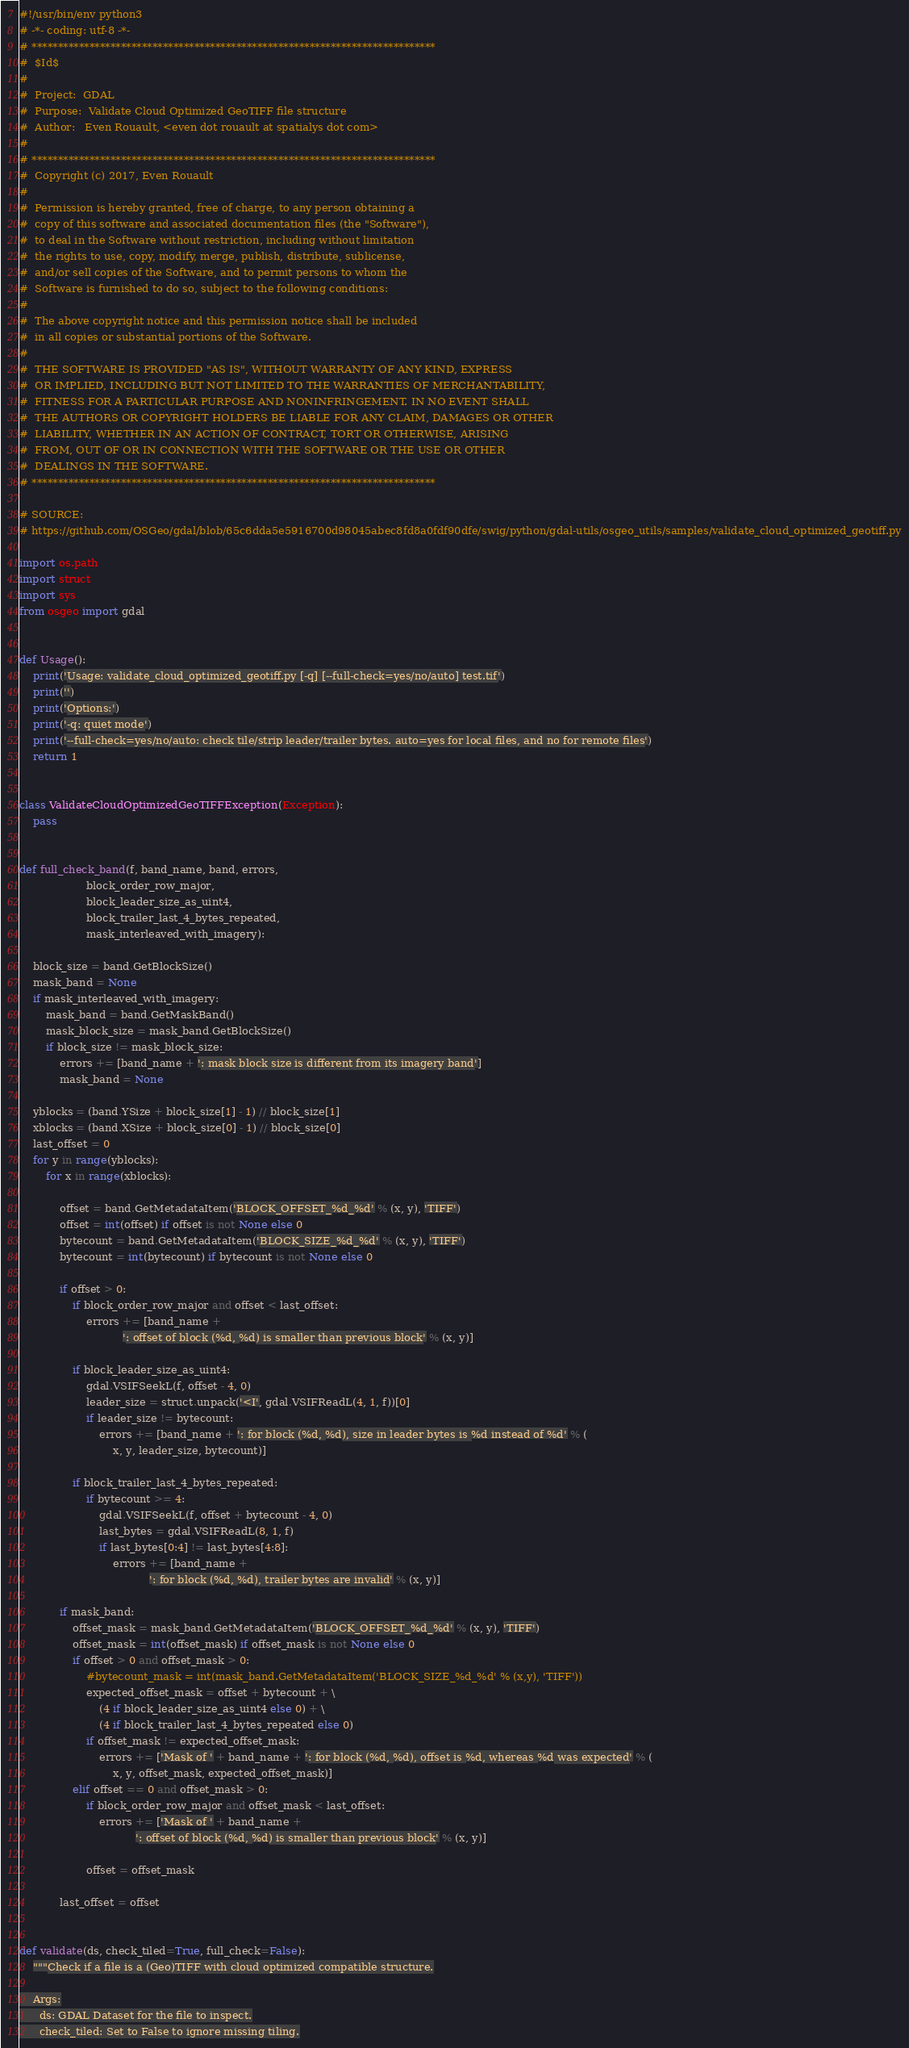<code> <loc_0><loc_0><loc_500><loc_500><_Python_>#!/usr/bin/env python3
# -*- coding: utf-8 -*-
# *****************************************************************************
#  $Id$
#
#  Project:  GDAL
#  Purpose:  Validate Cloud Optimized GeoTIFF file structure
#  Author:   Even Rouault, <even dot rouault at spatialys dot com>
#
# *****************************************************************************
#  Copyright (c) 2017, Even Rouault
#
#  Permission is hereby granted, free of charge, to any person obtaining a
#  copy of this software and associated documentation files (the "Software"),
#  to deal in the Software without restriction, including without limitation
#  the rights to use, copy, modify, merge, publish, distribute, sublicense,
#  and/or sell copies of the Software, and to permit persons to whom the
#  Software is furnished to do so, subject to the following conditions:
#
#  The above copyright notice and this permission notice shall be included
#  in all copies or substantial portions of the Software.
#
#  THE SOFTWARE IS PROVIDED "AS IS", WITHOUT WARRANTY OF ANY KIND, EXPRESS
#  OR IMPLIED, INCLUDING BUT NOT LIMITED TO THE WARRANTIES OF MERCHANTABILITY,
#  FITNESS FOR A PARTICULAR PURPOSE AND NONINFRINGEMENT. IN NO EVENT SHALL
#  THE AUTHORS OR COPYRIGHT HOLDERS BE LIABLE FOR ANY CLAIM, DAMAGES OR OTHER
#  LIABILITY, WHETHER IN AN ACTION OF CONTRACT, TORT OR OTHERWISE, ARISING
#  FROM, OUT OF OR IN CONNECTION WITH THE SOFTWARE OR THE USE OR OTHER
#  DEALINGS IN THE SOFTWARE.
# *****************************************************************************

# SOURCE:
# https://github.com/OSGeo/gdal/blob/65c6dda5e5916700d98045abec8fd8a0fdf90dfe/swig/python/gdal-utils/osgeo_utils/samples/validate_cloud_optimized_geotiff.py

import os.path
import struct
import sys
from osgeo import gdal


def Usage():
    print('Usage: validate_cloud_optimized_geotiff.py [-q] [--full-check=yes/no/auto] test.tif')
    print('')
    print('Options:')
    print('-q: quiet mode')
    print('--full-check=yes/no/auto: check tile/strip leader/trailer bytes. auto=yes for local files, and no for remote files')
    return 1


class ValidateCloudOptimizedGeoTIFFException(Exception):
    pass


def full_check_band(f, band_name, band, errors,
                    block_order_row_major,
                    block_leader_size_as_uint4,
                    block_trailer_last_4_bytes_repeated,
                    mask_interleaved_with_imagery):

    block_size = band.GetBlockSize()
    mask_band = None
    if mask_interleaved_with_imagery:
        mask_band = band.GetMaskBand()
        mask_block_size = mask_band.GetBlockSize()
        if block_size != mask_block_size:
            errors += [band_name + ': mask block size is different from its imagery band']
            mask_band = None

    yblocks = (band.YSize + block_size[1] - 1) // block_size[1]
    xblocks = (band.XSize + block_size[0] - 1) // block_size[0]
    last_offset = 0
    for y in range(yblocks):
        for x in range(xblocks):

            offset = band.GetMetadataItem('BLOCK_OFFSET_%d_%d' % (x, y), 'TIFF')
            offset = int(offset) if offset is not None else 0
            bytecount = band.GetMetadataItem('BLOCK_SIZE_%d_%d' % (x, y), 'TIFF')
            bytecount = int(bytecount) if bytecount is not None else 0

            if offset > 0:
                if block_order_row_major and offset < last_offset:
                    errors += [band_name +
                               ': offset of block (%d, %d) is smaller than previous block' % (x, y)]

                if block_leader_size_as_uint4:
                    gdal.VSIFSeekL(f, offset - 4, 0)
                    leader_size = struct.unpack('<I', gdal.VSIFReadL(4, 1, f))[0]
                    if leader_size != bytecount:
                        errors += [band_name + ': for block (%d, %d), size in leader bytes is %d instead of %d' % (
                            x, y, leader_size, bytecount)]

                if block_trailer_last_4_bytes_repeated:
                    if bytecount >= 4:
                        gdal.VSIFSeekL(f, offset + bytecount - 4, 0)
                        last_bytes = gdal.VSIFReadL(8, 1, f)
                        if last_bytes[0:4] != last_bytes[4:8]:
                            errors += [band_name +
                                       ': for block (%d, %d), trailer bytes are invalid' % (x, y)]

            if mask_band:
                offset_mask = mask_band.GetMetadataItem('BLOCK_OFFSET_%d_%d' % (x, y), 'TIFF')
                offset_mask = int(offset_mask) if offset_mask is not None else 0
                if offset > 0 and offset_mask > 0:
                    #bytecount_mask = int(mask_band.GetMetadataItem('BLOCK_SIZE_%d_%d' % (x,y), 'TIFF'))
                    expected_offset_mask = offset + bytecount + \
                        (4 if block_leader_size_as_uint4 else 0) + \
                        (4 if block_trailer_last_4_bytes_repeated else 0)
                    if offset_mask != expected_offset_mask:
                        errors += ['Mask of ' + band_name + ': for block (%d, %d), offset is %d, whereas %d was expected' % (
                            x, y, offset_mask, expected_offset_mask)]
                elif offset == 0 and offset_mask > 0:
                    if block_order_row_major and offset_mask < last_offset:
                        errors += ['Mask of ' + band_name +
                                   ': offset of block (%d, %d) is smaller than previous block' % (x, y)]

                    offset = offset_mask

            last_offset = offset


def validate(ds, check_tiled=True, full_check=False):
    """Check if a file is a (Geo)TIFF with cloud optimized compatible structure.

    Args:
      ds: GDAL Dataset for the file to inspect.
      check_tiled: Set to False to ignore missing tiling.</code> 